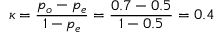Convert formula to latex. <formula><loc_0><loc_0><loc_500><loc_500>\kappa = { \frac { p _ { o } - p _ { e } } { 1 - p _ { e } } } = { \frac { 0 . 7 - 0 . 5 } { 1 - 0 . 5 } } = 0 . 4</formula> 